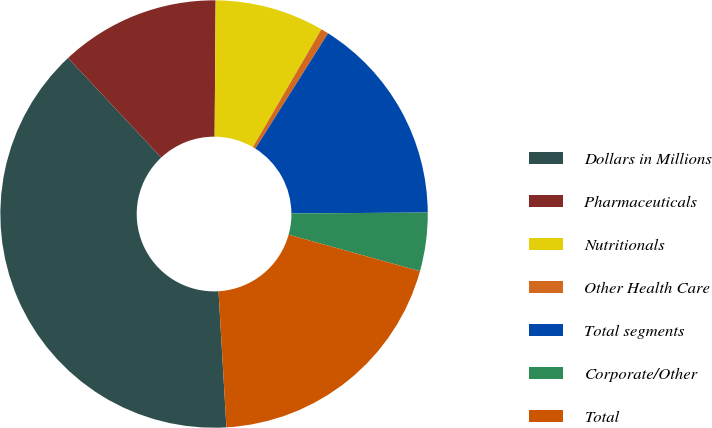<chart> <loc_0><loc_0><loc_500><loc_500><pie_chart><fcel>Dollars in Millions<fcel>Pharmaceuticals<fcel>Nutritionals<fcel>Other Health Care<fcel>Total segments<fcel>Corporate/Other<fcel>Total<nl><fcel>38.95%<fcel>12.09%<fcel>8.26%<fcel>0.58%<fcel>15.93%<fcel>4.42%<fcel>19.77%<nl></chart> 